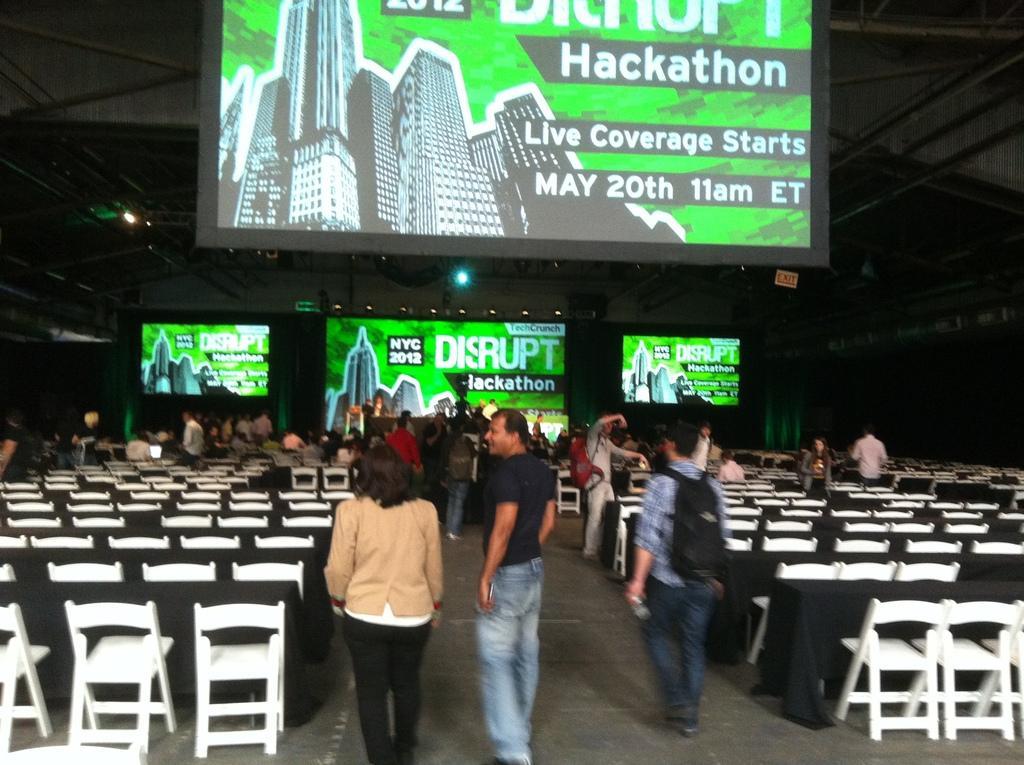In one or two sentences, can you explain what this image depicts? In this image we can see some people standing. We can also see some people sitting on the chairs. Image also consists of many empty chairs and also the tables which are covered with black color clothes. We can also see the hoardings with text. We can also see the lights and also the roof and at the bottom we can see the surface. 